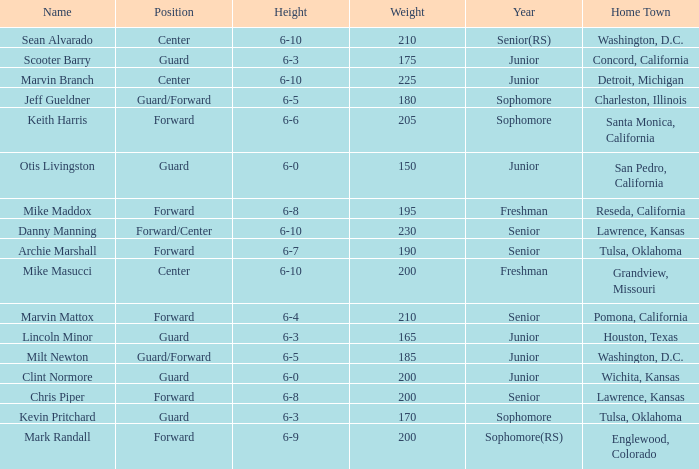Can you tell me the average Weight that has Height of 6-9? 200.0. 